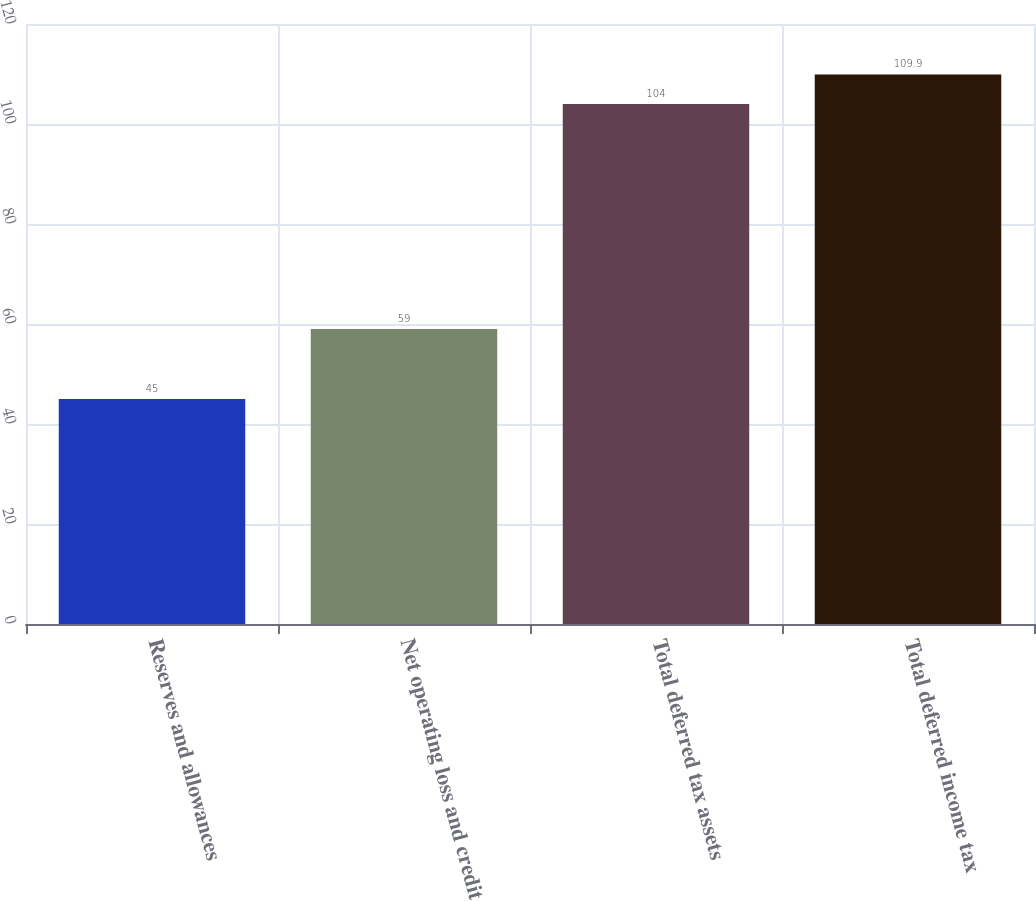<chart> <loc_0><loc_0><loc_500><loc_500><bar_chart><fcel>Reserves and allowances<fcel>Net operating loss and credit<fcel>Total deferred tax assets<fcel>Total deferred income tax<nl><fcel>45<fcel>59<fcel>104<fcel>109.9<nl></chart> 